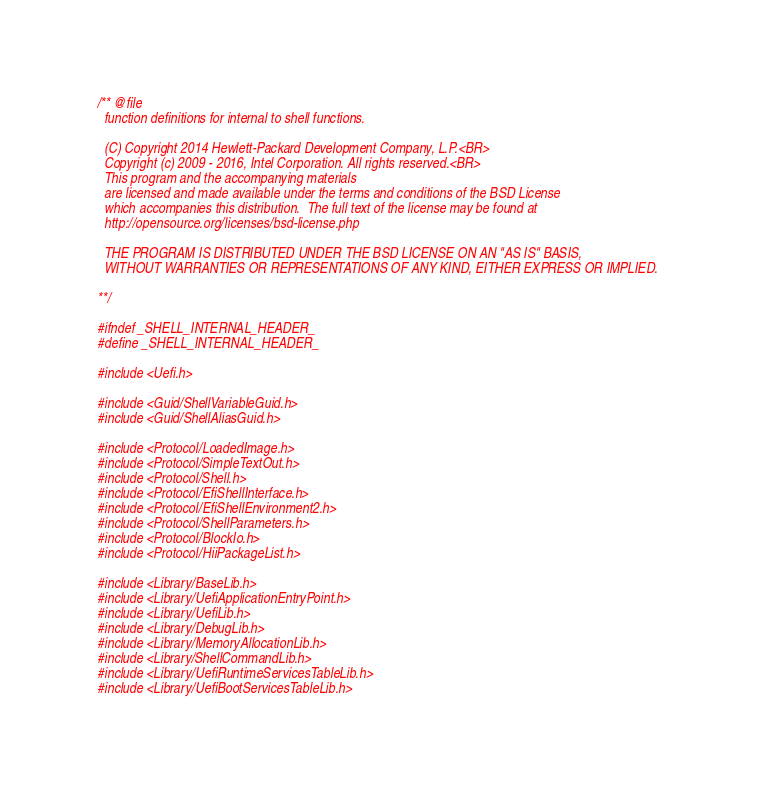Convert code to text. <code><loc_0><loc_0><loc_500><loc_500><_C_>/** @file
  function definitions for internal to shell functions.

  (C) Copyright 2014 Hewlett-Packard Development Company, L.P.<BR>
  Copyright (c) 2009 - 2016, Intel Corporation. All rights reserved.<BR>
  This program and the accompanying materials
  are licensed and made available under the terms and conditions of the BSD License
  which accompanies this distribution.  The full text of the license may be found at
  http://opensource.org/licenses/bsd-license.php

  THE PROGRAM IS DISTRIBUTED UNDER THE BSD LICENSE ON AN "AS IS" BASIS,
  WITHOUT WARRANTIES OR REPRESENTATIONS OF ANY KIND, EITHER EXPRESS OR IMPLIED.

**/

#ifndef _SHELL_INTERNAL_HEADER_
#define _SHELL_INTERNAL_HEADER_

#include <Uefi.h>

#include <Guid/ShellVariableGuid.h>
#include <Guid/ShellAliasGuid.h>

#include <Protocol/LoadedImage.h>
#include <Protocol/SimpleTextOut.h>
#include <Protocol/Shell.h>
#include <Protocol/EfiShellInterface.h>
#include <Protocol/EfiShellEnvironment2.h>
#include <Protocol/ShellParameters.h>
#include <Protocol/BlockIo.h>
#include <Protocol/HiiPackageList.h>

#include <Library/BaseLib.h>
#include <Library/UefiApplicationEntryPoint.h>
#include <Library/UefiLib.h>
#include <Library/DebugLib.h>
#include <Library/MemoryAllocationLib.h>
#include <Library/ShellCommandLib.h>
#include <Library/UefiRuntimeServicesTableLib.h>
#include <Library/UefiBootServicesTableLib.h></code> 